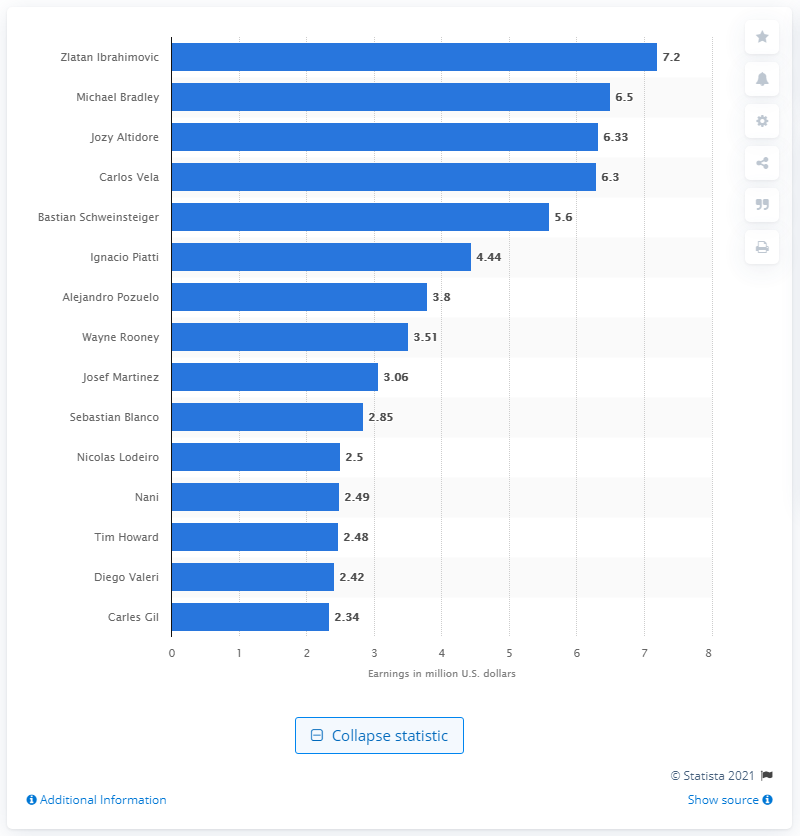Draw attention to some important aspects in this diagram. The total earnings of Michael Bradley and Giovani dos Santos for the year was 6.5 million USD. As of 2023, Zlatan Ibrahimovic's base salary is $7.2 million. 